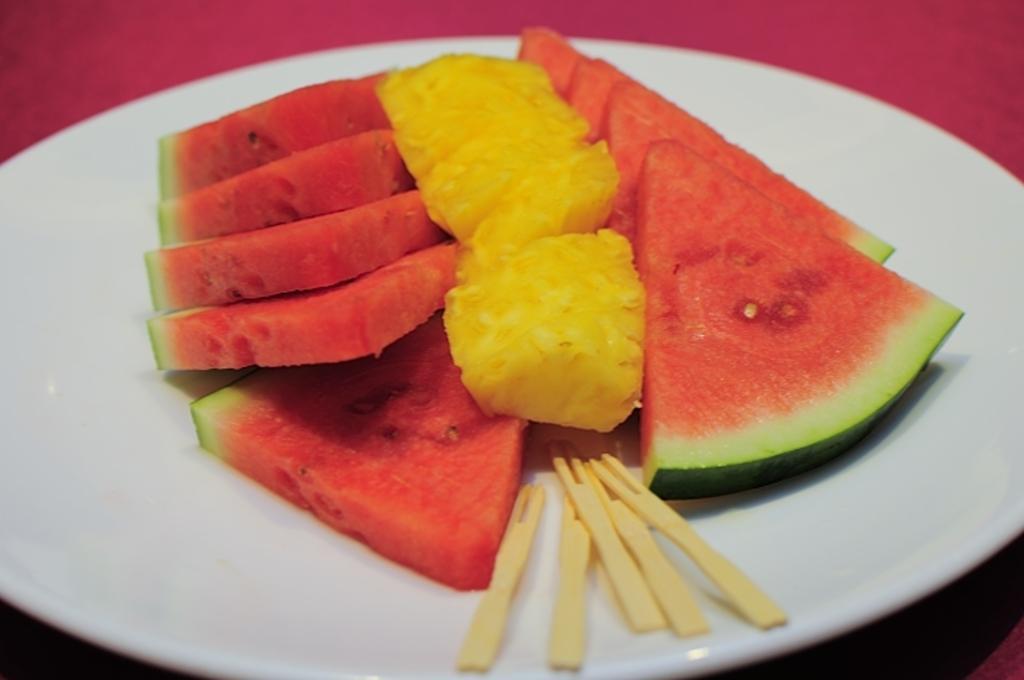Describe this image in one or two sentences. In this image I can see the pieces of watermelon and pineapple in the plate. I can also see the sticks on the plate. The plate is on the pink color surface. 